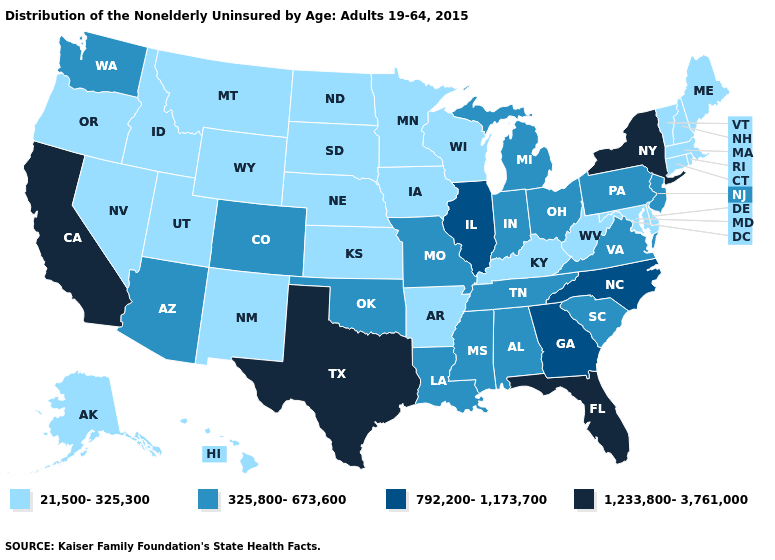What is the value of California?
Concise answer only. 1,233,800-3,761,000. Name the states that have a value in the range 21,500-325,300?
Give a very brief answer. Alaska, Arkansas, Connecticut, Delaware, Hawaii, Idaho, Iowa, Kansas, Kentucky, Maine, Maryland, Massachusetts, Minnesota, Montana, Nebraska, Nevada, New Hampshire, New Mexico, North Dakota, Oregon, Rhode Island, South Dakota, Utah, Vermont, West Virginia, Wisconsin, Wyoming. How many symbols are there in the legend?
Answer briefly. 4. Among the states that border Kentucky , does West Virginia have the lowest value?
Keep it brief. Yes. Among the states that border Connecticut , does Massachusetts have the highest value?
Short answer required. No. Name the states that have a value in the range 21,500-325,300?
Keep it brief. Alaska, Arkansas, Connecticut, Delaware, Hawaii, Idaho, Iowa, Kansas, Kentucky, Maine, Maryland, Massachusetts, Minnesota, Montana, Nebraska, Nevada, New Hampshire, New Mexico, North Dakota, Oregon, Rhode Island, South Dakota, Utah, Vermont, West Virginia, Wisconsin, Wyoming. Name the states that have a value in the range 21,500-325,300?
Write a very short answer. Alaska, Arkansas, Connecticut, Delaware, Hawaii, Idaho, Iowa, Kansas, Kentucky, Maine, Maryland, Massachusetts, Minnesota, Montana, Nebraska, Nevada, New Hampshire, New Mexico, North Dakota, Oregon, Rhode Island, South Dakota, Utah, Vermont, West Virginia, Wisconsin, Wyoming. What is the highest value in the USA?
Short answer required. 1,233,800-3,761,000. Name the states that have a value in the range 325,800-673,600?
Quick response, please. Alabama, Arizona, Colorado, Indiana, Louisiana, Michigan, Mississippi, Missouri, New Jersey, Ohio, Oklahoma, Pennsylvania, South Carolina, Tennessee, Virginia, Washington. Name the states that have a value in the range 325,800-673,600?
Short answer required. Alabama, Arizona, Colorado, Indiana, Louisiana, Michigan, Mississippi, Missouri, New Jersey, Ohio, Oklahoma, Pennsylvania, South Carolina, Tennessee, Virginia, Washington. Name the states that have a value in the range 325,800-673,600?
Give a very brief answer. Alabama, Arizona, Colorado, Indiana, Louisiana, Michigan, Mississippi, Missouri, New Jersey, Ohio, Oklahoma, Pennsylvania, South Carolina, Tennessee, Virginia, Washington. Is the legend a continuous bar?
Quick response, please. No. What is the highest value in states that border Kansas?
Concise answer only. 325,800-673,600. What is the lowest value in the MidWest?
Concise answer only. 21,500-325,300. Name the states that have a value in the range 325,800-673,600?
Write a very short answer. Alabama, Arizona, Colorado, Indiana, Louisiana, Michigan, Mississippi, Missouri, New Jersey, Ohio, Oklahoma, Pennsylvania, South Carolina, Tennessee, Virginia, Washington. 